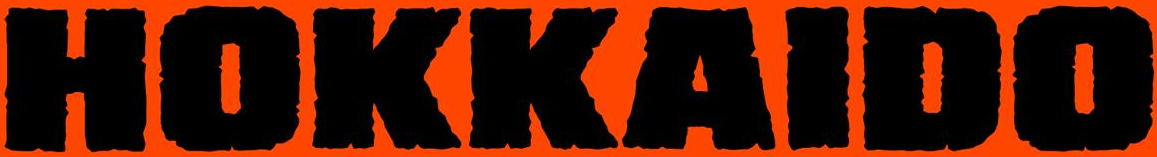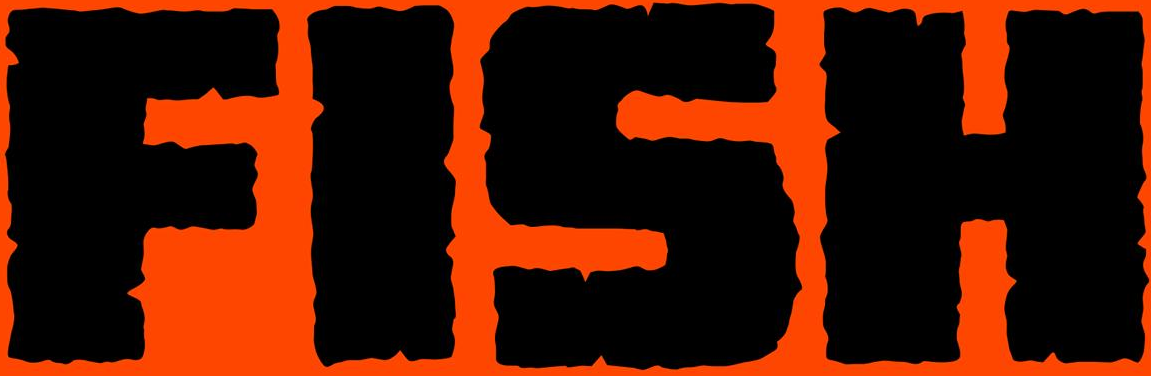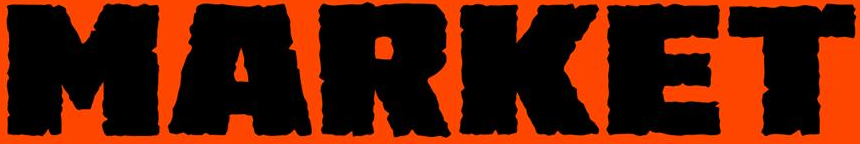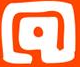Read the text content from these images in order, separated by a semicolon. HOKKAIDO; FISH; MARKET; @ 